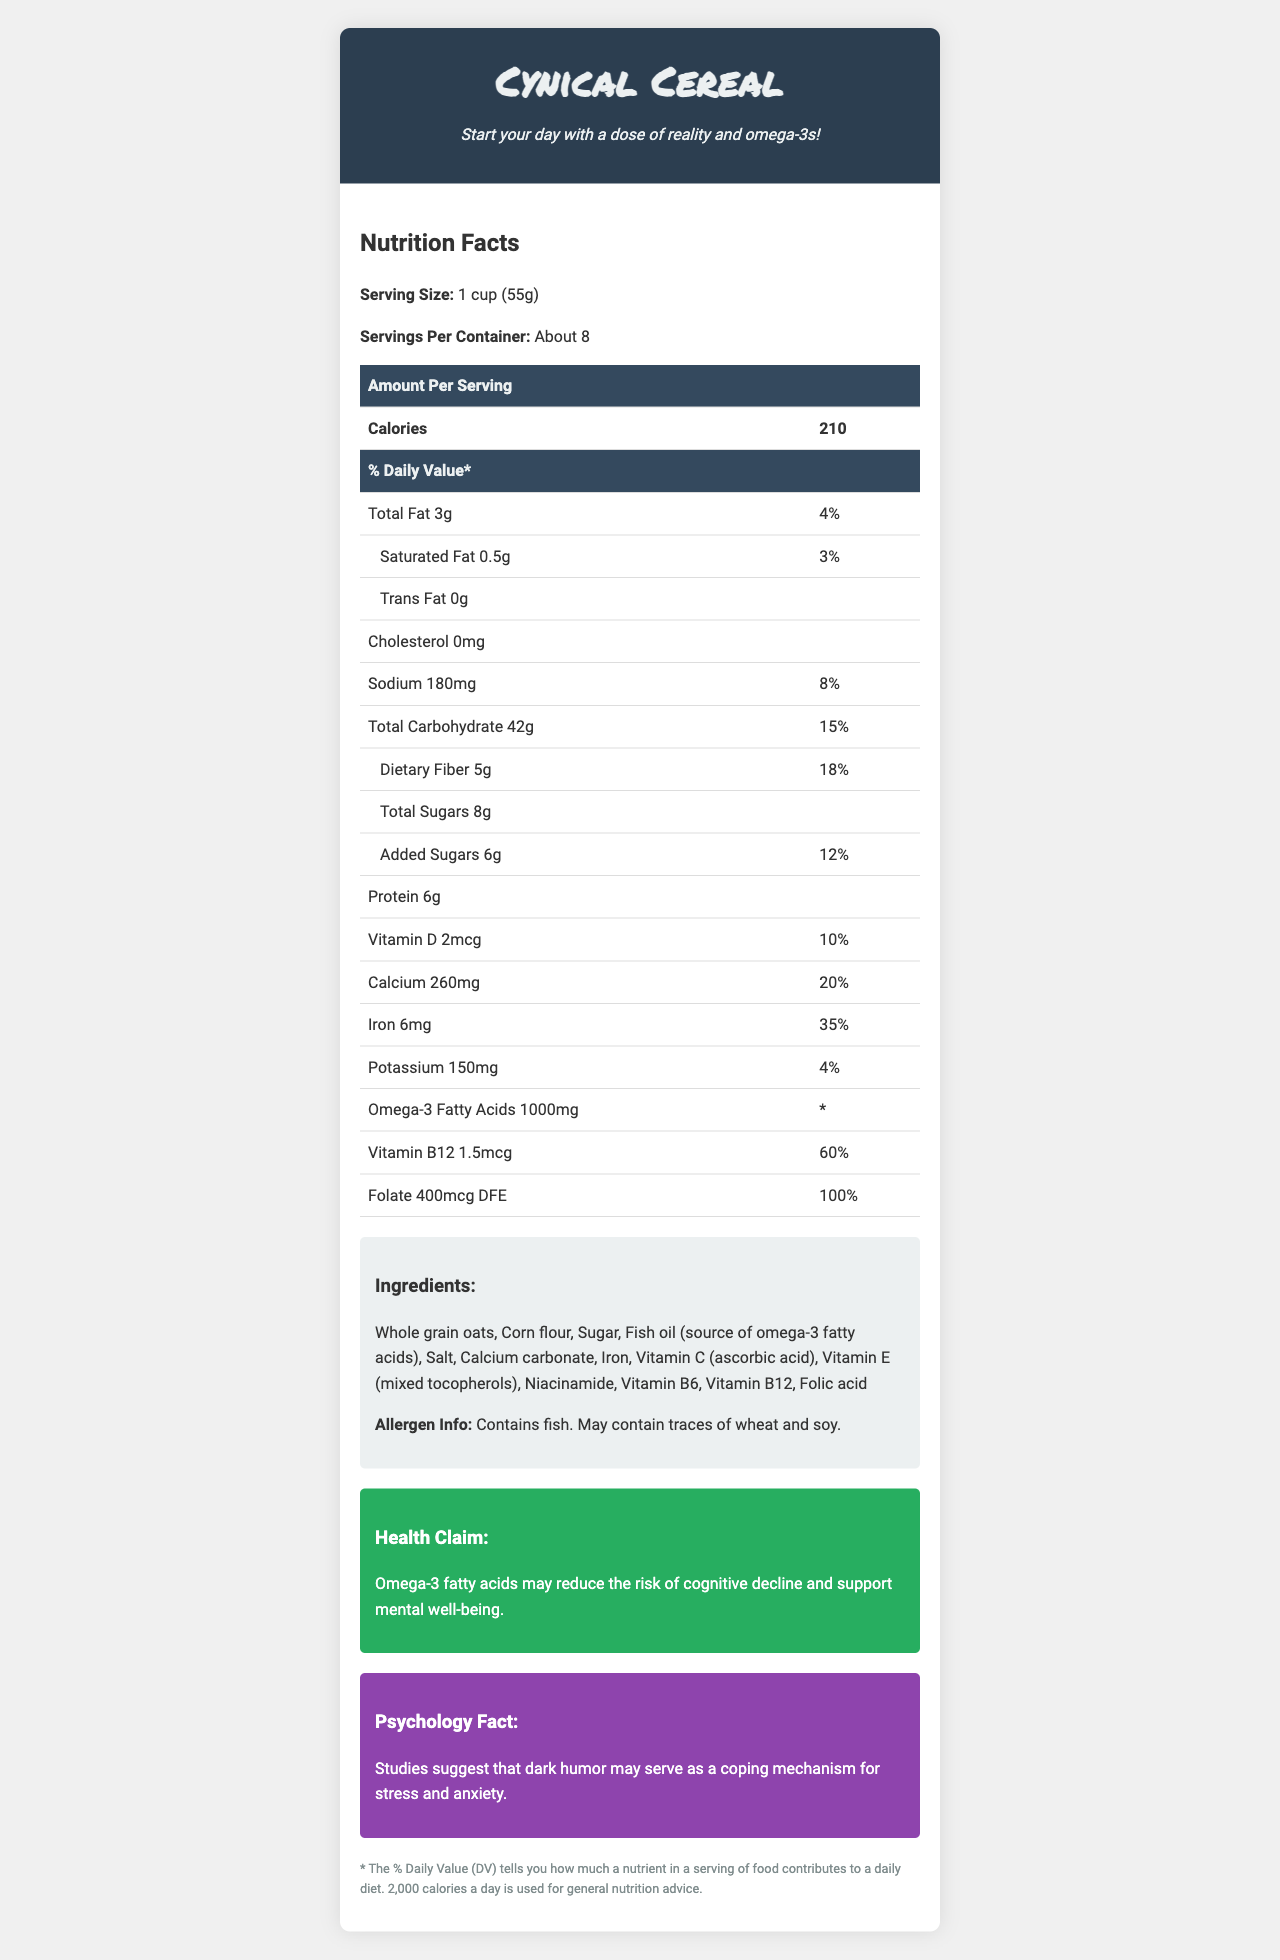what is the serving size for Cynical Cereal? The serving size is clearly listed as "1 cup (55g)" on the document.
Answer: 1 cup (55g) how many calories are in one serving of Cynical Cereal? The document states that each serving contains 210 calories.
Answer: 210 what is the % Daily Value of dietary fiber in one serving? The document lists dietary fiber as "5g", which contributes to 18% of the Daily Value.
Answer: 18% what ingredient is the source of omega-3 fatty acids? The ingredient list includes "Fish oil (source of omega-3 fatty acids)".
Answer: Fish oil What is the health claim associated with Cynical Cereal? This statement is under the "Health Claim" section of the document.
Answer: Omega-3 fatty acids may reduce the risk of cognitive decline and support mental well-being. how much vitamin B12 is in each serving? The document lists 1.5mcg under the Vitamin B12 amount per serving.
Answer: 1.5mcg Does Cynical Cereal contain any trans fat? The document states that it contains 0g trans fat.
Answer: No what is the serving size of Cynical Cereal? A. 1/2 cup B. 1 cup C. 1 1/2 cup D. 2 cups The serving size listed in the document is 1 cup (55g).
Answer: B which nutrient has the highest % Daily Value per serving? A. Iron B. Calcium C. Folate D. Protein The nutrient with the highest % Daily Value per serving is Folate at 100%.
Answer: C Is there any cholesterol in Cynical Cereal? The document indicates that there is 0mg of cholesterol.
Answer: No Summarize the main idea of the document. The document details the nutritional content and health claims of Cynical Cereal. It emphasizes the presence of brain-benefiting omega-3 fatty acids while also noting other nutritional facts and the "cynical" tagline.
Answer: Cynical Cereal is a breakfast product that provides a variety of nutrients, including omega-3 fatty acids for brain health. It promotes the potential benefits of Omega-3 fatty acids in reducing cognitive decline. The cereal contains no trans fat or cholesterol, but contains fish oil as an essential ingredient. It also humorously claims to provide a "dose of reality" with its nutrition. What is the cynical tagline of Cynical Cereal? The tagline is displayed prominently in the header section of the document.
Answer: Start your day with a dose of reality and omega-3s! can a person with a fish allergy consume Cynical Cereal safely? The document lists fish as an ingredient and potential allergen, so it is not safe for those with a fish allergy.
Answer: No How is dietary fiber classified on the nutrition facts label? Dietary Fiber is listed under the "Total Carbohydrate" section of the nutrition facts label.
Answer: Total Carbohydrate What type of psychological coping mechanism is dark humor suggested to be associated with? The "Psychology Fact" section states that dark humor may serve as a coping mechanism for stress and anxiety.
Answer: Stress and anxiety What percentage of daily calcium needs does one serving meet? The document shows that one serving meets 20% of the daily calcium needs.
Answer: 20% Is there information on whether the product is gluten-free or not? The document does not provide sufficient information to determine whether Cynical Cereal is gluten-free.
Answer: Not enough information 